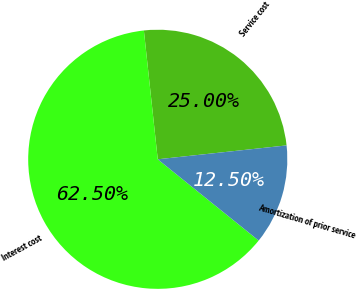Convert chart. <chart><loc_0><loc_0><loc_500><loc_500><pie_chart><fcel>Service cost<fcel>Interest cost<fcel>Amortization of prior service<nl><fcel>25.0%<fcel>62.5%<fcel>12.5%<nl></chart> 